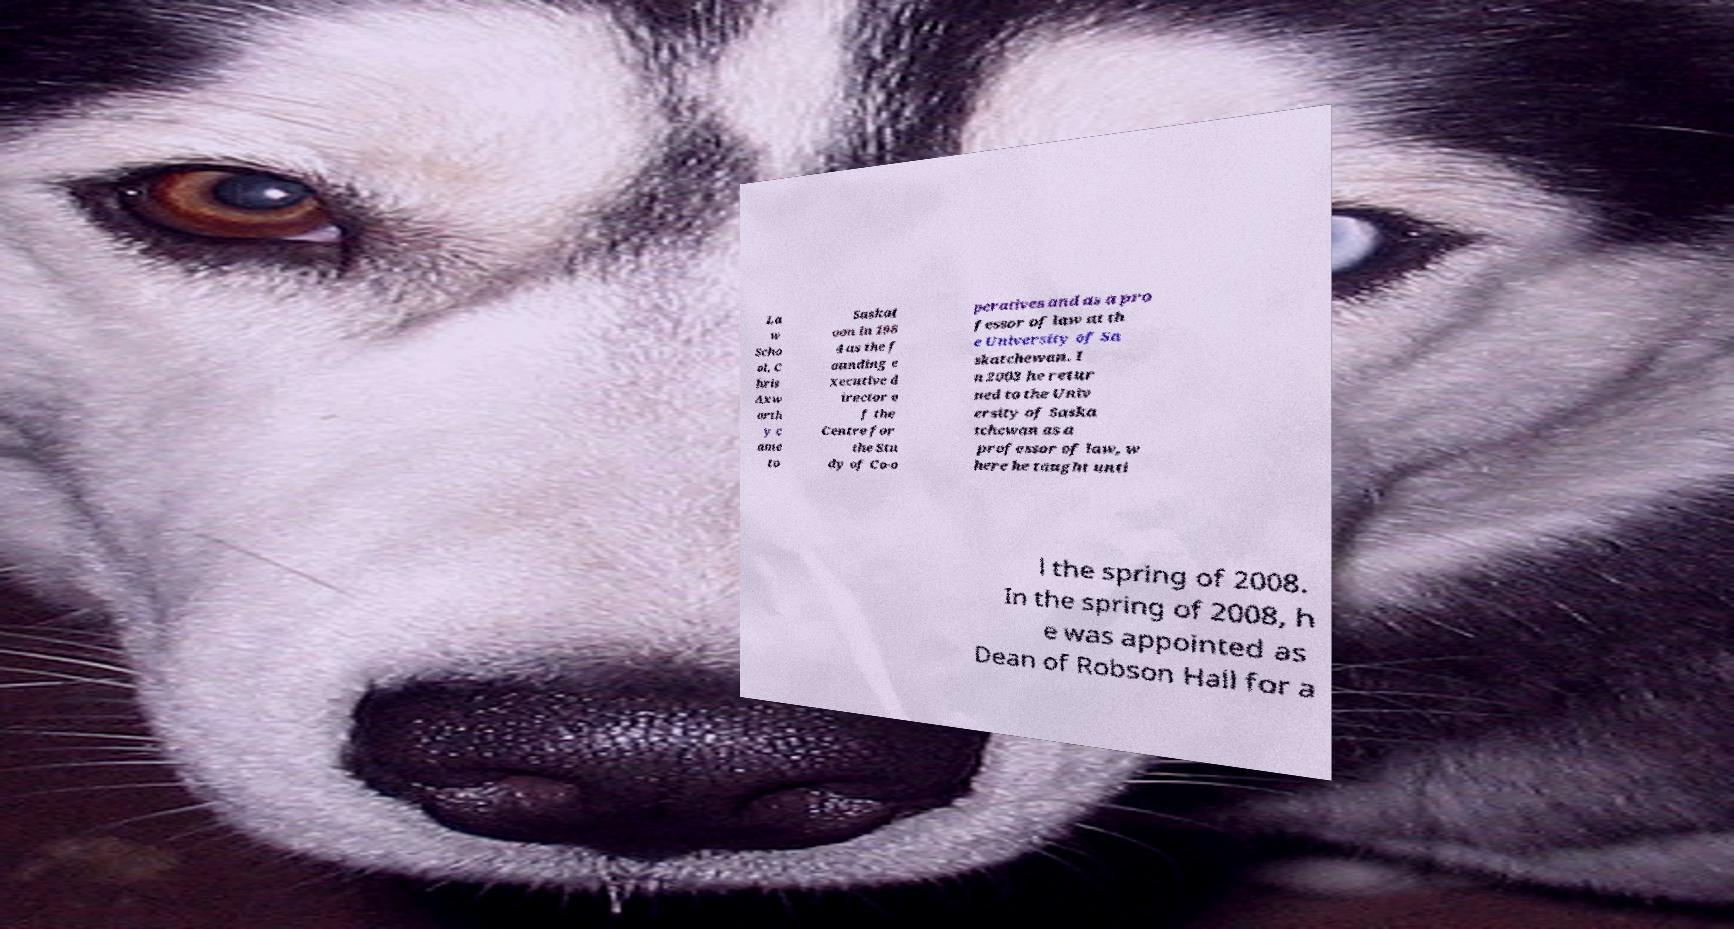Please read and relay the text visible in this image. What does it say? La w Scho ol, C hris Axw orth y c ame to Saskat oon in 198 4 as the f ounding e xecutive d irector o f the Centre for the Stu dy of Co-o peratives and as a pro fessor of law at th e University of Sa skatchewan. I n 2003 he retur ned to the Univ ersity of Saska tchewan as a professor of law, w here he taught unti l the spring of 2008. In the spring of 2008, h e was appointed as Dean of Robson Hall for a 